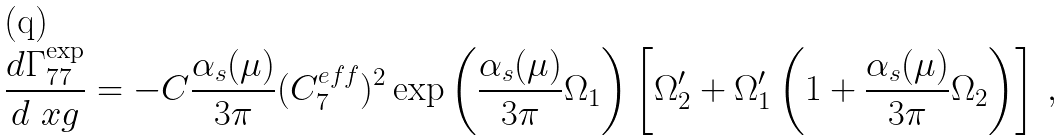<formula> <loc_0><loc_0><loc_500><loc_500>\frac { d \Gamma _ { 7 7 } ^ { \exp } } { d \ x g } = - C \frac { \alpha _ { s } ( \mu ) } { 3 \pi } ( C _ { 7 } ^ { e f f } ) ^ { 2 } \exp \left ( \frac { \alpha _ { s } ( \mu ) } { 3 \pi } \Omega _ { 1 } \right ) \left [ \Omega _ { 2 } ^ { \prime } + \Omega _ { 1 } ^ { \prime } \left ( 1 + \frac { \alpha _ { s } ( \mu ) } { 3 \pi } \Omega _ { 2 } \right ) \right ] \, ,</formula> 